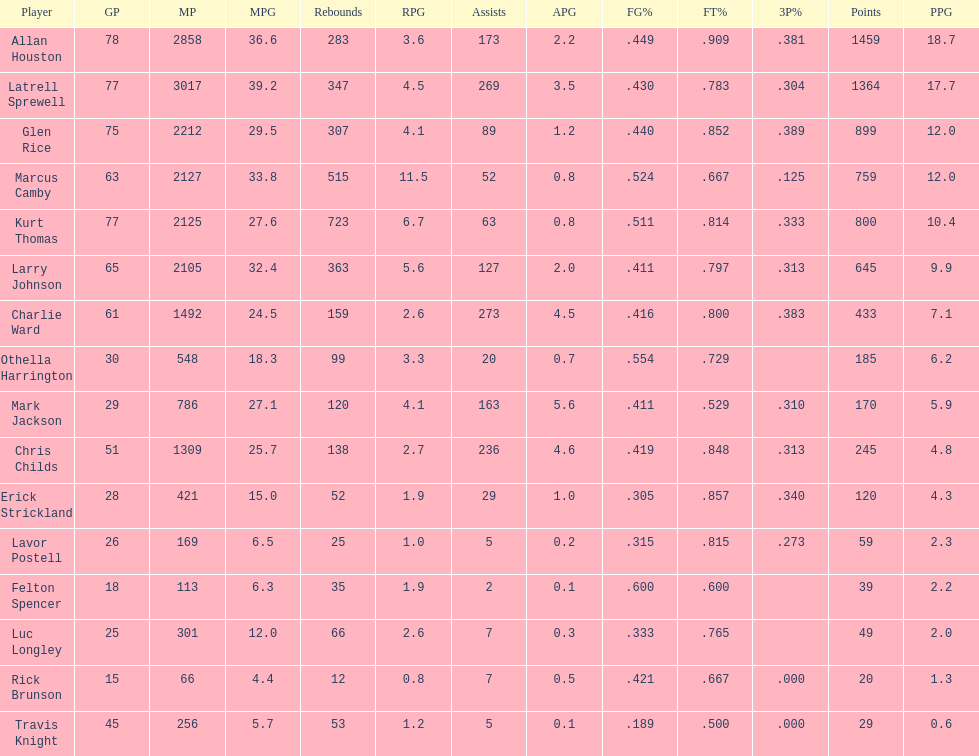Can you give me this table as a dict? {'header': ['Player', 'GP', 'MP', 'MPG', 'Rebounds', 'RPG', 'Assists', 'APG', 'FG%', 'FT%', '3P%', 'Points', 'PPG'], 'rows': [['Allan Houston', '78', '2858', '36.6', '283', '3.6', '173', '2.2', '.449', '.909', '.381', '1459', '18.7'], ['Latrell Sprewell', '77', '3017', '39.2', '347', '4.5', '269', '3.5', '.430', '.783', '.304', '1364', '17.7'], ['Glen Rice', '75', '2212', '29.5', '307', '4.1', '89', '1.2', '.440', '.852', '.389', '899', '12.0'], ['Marcus Camby', '63', '2127', '33.8', '515', '11.5', '52', '0.8', '.524', '.667', '.125', '759', '12.0'], ['Kurt Thomas', '77', '2125', '27.6', '723', '6.7', '63', '0.8', '.511', '.814', '.333', '800', '10.4'], ['Larry Johnson', '65', '2105', '32.4', '363', '5.6', '127', '2.0', '.411', '.797', '.313', '645', '9.9'], ['Charlie Ward', '61', '1492', '24.5', '159', '2.6', '273', '4.5', '.416', '.800', '.383', '433', '7.1'], ['Othella Harrington', '30', '548', '18.3', '99', '3.3', '20', '0.7', '.554', '.729', '', '185', '6.2'], ['Mark Jackson', '29', '786', '27.1', '120', '4.1', '163', '5.6', '.411', '.529', '.310', '170', '5.9'], ['Chris Childs', '51', '1309', '25.7', '138', '2.7', '236', '4.6', '.419', '.848', '.313', '245', '4.8'], ['Erick Strickland', '28', '421', '15.0', '52', '1.9', '29', '1.0', '.305', '.857', '.340', '120', '4.3'], ['Lavor Postell', '26', '169', '6.5', '25', '1.0', '5', '0.2', '.315', '.815', '.273', '59', '2.3'], ['Felton Spencer', '18', '113', '6.3', '35', '1.9', '2', '0.1', '.600', '.600', '', '39', '2.2'], ['Luc Longley', '25', '301', '12.0', '66', '2.6', '7', '0.3', '.333', '.765', '', '49', '2.0'], ['Rick Brunson', '15', '66', '4.4', '12', '0.8', '7', '0.5', '.421', '.667', '.000', '20', '1.3'], ['Travis Knight', '45', '256', '5.7', '53', '1.2', '5', '0.1', '.189', '.500', '.000', '29', '0.6']]} Did kurt thomas play more or less than 2126 minutes? Less. 